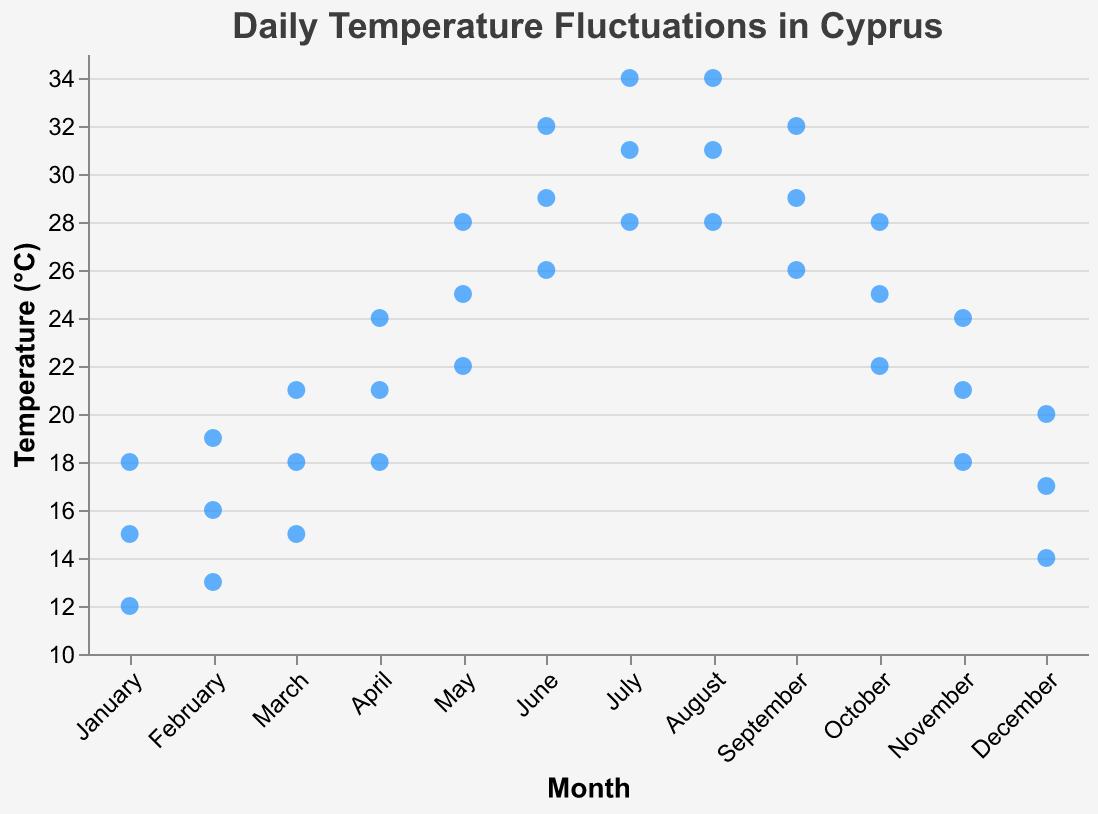What is the title of the plot? The title can be found at the top of the plot. It is usually set in a slightly larger and bolder font compared to other text in the figure.
Answer: Daily Temperature Fluctuations in Cyprus In which month is the highest temperature recorded and what is that temperature? By looking at the y-axis for the temperature range and the x-axis for months, we observe that the highest temperature is recorded in July and August at 34°C.
Answer: July and August, 34°C Which month experiences the lowest recorded temperature and what is that temperature? Check the lowest point in the plot along the y-axis, and the corresponding month from the x-axis. The lowest temperature recorded is in January at 12°C.
Answer: January, 12°C What's the temperature range for March? Find the minimum and maximum temperatures recorded in March from the plot. In March, the temperatures range from 15°C to 21°C.
Answer: 15°C to 21°C Compare the temperature range in April and November. Identify the highest and lowest temperatures recorded in both April (18°C to 24°C) and November (18°C to 24°C). Both months have the same temperature range.
Answer: April and November have the same range: 18°C to 24°C What is the mean temperature for May? To find the mean, sum the temperatures recorded in May (22°C, 25°C, 28°C) and divide by the number of readings: (22 + 25 + 28) / 3 = 75 / 3 = 25°C.
Answer: 25°C Which month has more temperature fluctuation: June or August? Calculate the difference between the highest and lowest temperatures for both June (32°C - 26°C = 6°C) and August (34°C - 28°C = 6°C). Both have the same fluctuation.
Answer: Both have equal fluctuation: 6°C What is the median temperature in December? Arrange December temperatures (14°C, 17°C, 20°C) and determine the middle value. The median is 17°C.
Answer: 17°C Which month has the most evenly spread temperature readings throughout the range? Assessment based on visual spread along the y-axis in respective months; January (12°C to 18°C) seems most evenly spread as it covers a uniform distribution.
Answer: January 